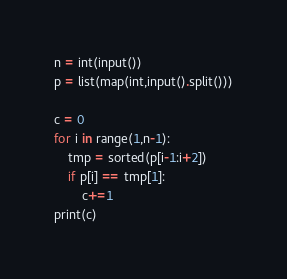<code> <loc_0><loc_0><loc_500><loc_500><_Python_>n = int(input())
p = list(map(int,input().split()))

c = 0
for i in range(1,n-1):
    tmp = sorted(p[i-1:i+2])
    if p[i] == tmp[1]:
        c+=1
print(c)   
</code> 